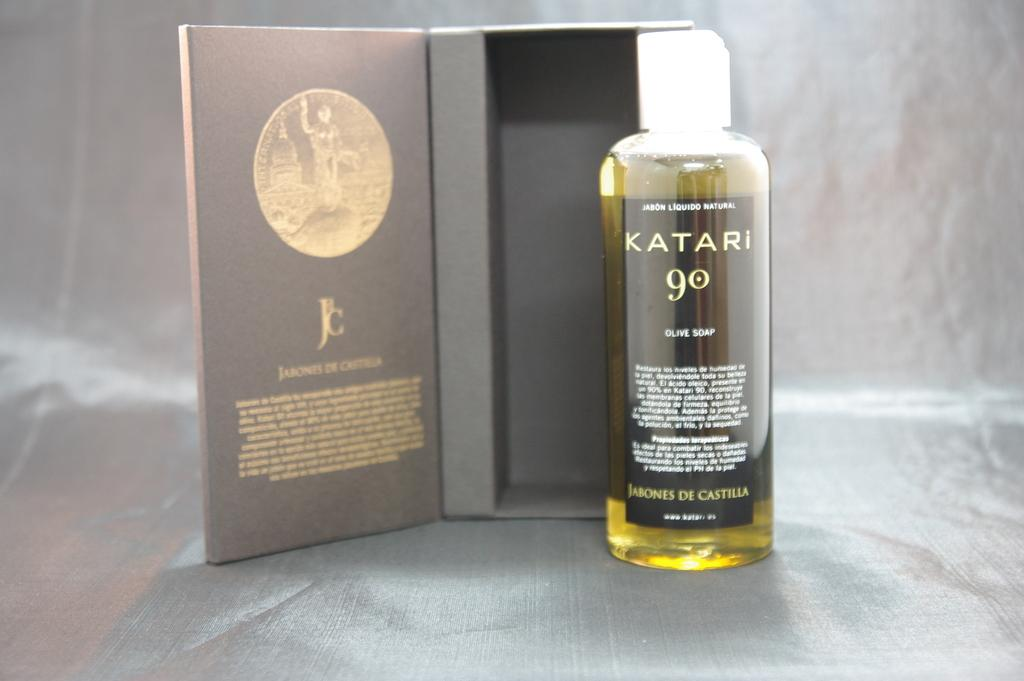Provide a one-sentence caption for the provided image. A bottle of Katari 90 olive soap is shown outside of a well structured packaging box. 